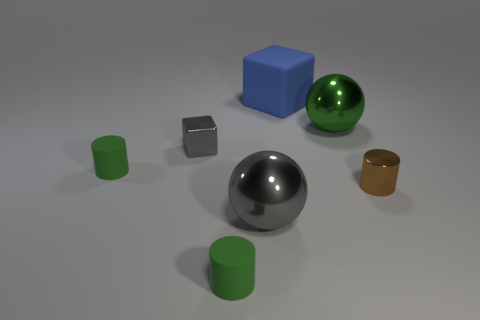Subtract all tiny matte cylinders. How many cylinders are left? 1 Subtract all red balls. How many green cylinders are left? 2 Subtract all gray blocks. How many blocks are left? 1 Subtract 1 cylinders. How many cylinders are left? 2 Add 1 blocks. How many objects exist? 8 Subtract all blocks. How many objects are left? 5 Add 1 big green metal balls. How many big green metal balls are left? 2 Add 1 large rubber objects. How many large rubber objects exist? 2 Subtract 1 gray cubes. How many objects are left? 6 Subtract all gray cylinders. Subtract all purple balls. How many cylinders are left? 3 